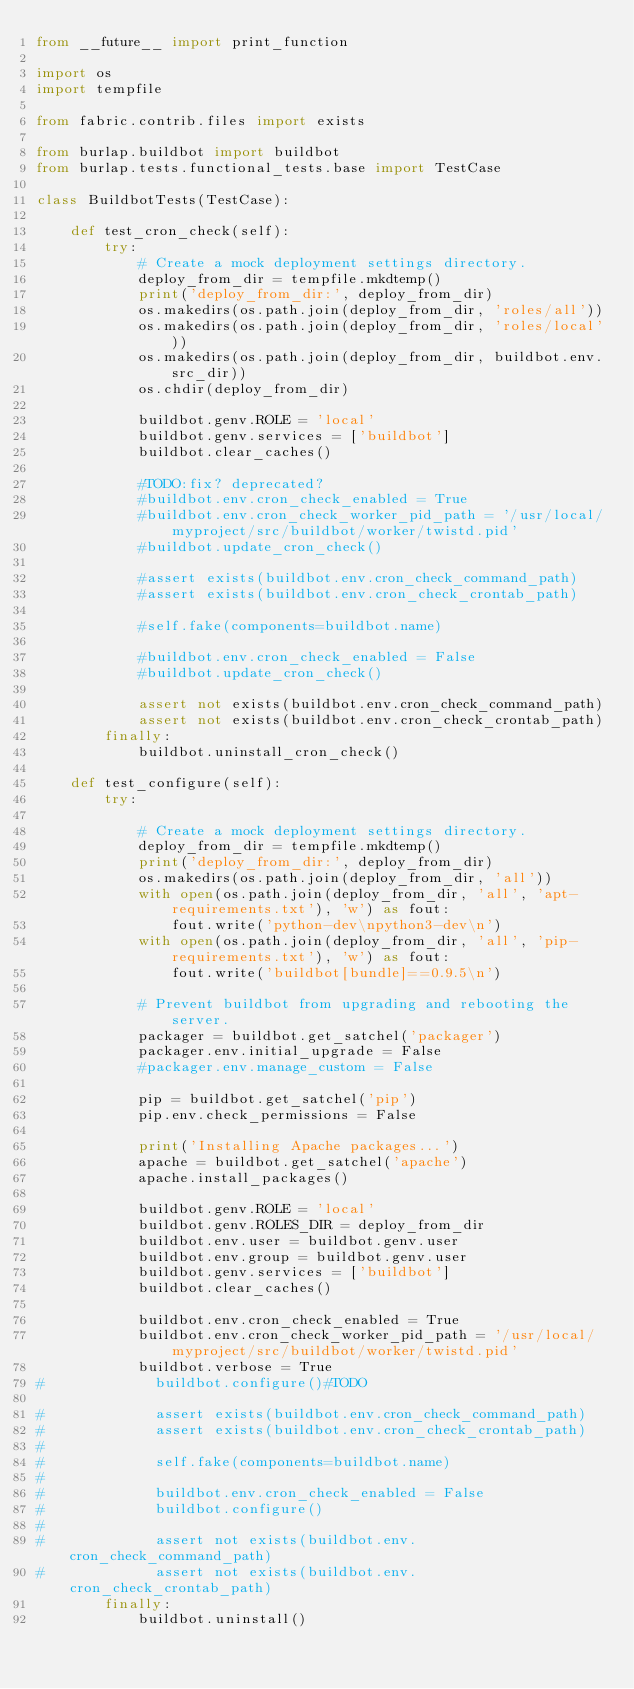Convert code to text. <code><loc_0><loc_0><loc_500><loc_500><_Python_>from __future__ import print_function

import os
import tempfile

from fabric.contrib.files import exists

from burlap.buildbot import buildbot
from burlap.tests.functional_tests.base import TestCase

class BuildbotTests(TestCase):

    def test_cron_check(self):
        try:
            # Create a mock deployment settings directory.
            deploy_from_dir = tempfile.mkdtemp()
            print('deploy_from_dir:', deploy_from_dir)
            os.makedirs(os.path.join(deploy_from_dir, 'roles/all'))
            os.makedirs(os.path.join(deploy_from_dir, 'roles/local'))
            os.makedirs(os.path.join(deploy_from_dir, buildbot.env.src_dir))
            os.chdir(deploy_from_dir)

            buildbot.genv.ROLE = 'local'
            buildbot.genv.services = ['buildbot']
            buildbot.clear_caches()

            #TODO:fix? deprecated?
            #buildbot.env.cron_check_enabled = True
            #buildbot.env.cron_check_worker_pid_path = '/usr/local/myproject/src/buildbot/worker/twistd.pid'
            #buildbot.update_cron_check()

            #assert exists(buildbot.env.cron_check_command_path)
            #assert exists(buildbot.env.cron_check_crontab_path)

            #self.fake(components=buildbot.name)

            #buildbot.env.cron_check_enabled = False
            #buildbot.update_cron_check()

            assert not exists(buildbot.env.cron_check_command_path)
            assert not exists(buildbot.env.cron_check_crontab_path)
        finally:
            buildbot.uninstall_cron_check()

    def test_configure(self):
        try:

            # Create a mock deployment settings directory.
            deploy_from_dir = tempfile.mkdtemp()
            print('deploy_from_dir:', deploy_from_dir)
            os.makedirs(os.path.join(deploy_from_dir, 'all'))
            with open(os.path.join(deploy_from_dir, 'all', 'apt-requirements.txt'), 'w') as fout:
                fout.write('python-dev\npython3-dev\n')
            with open(os.path.join(deploy_from_dir, 'all', 'pip-requirements.txt'), 'w') as fout:
                fout.write('buildbot[bundle]==0.9.5\n')

            # Prevent buildbot from upgrading and rebooting the server.
            packager = buildbot.get_satchel('packager')
            packager.env.initial_upgrade = False
            #packager.env.manage_custom = False

            pip = buildbot.get_satchel('pip')
            pip.env.check_permissions = False

            print('Installing Apache packages...')
            apache = buildbot.get_satchel('apache')
            apache.install_packages()

            buildbot.genv.ROLE = 'local'
            buildbot.genv.ROLES_DIR = deploy_from_dir
            buildbot.env.user = buildbot.genv.user
            buildbot.env.group = buildbot.genv.user
            buildbot.genv.services = ['buildbot']
            buildbot.clear_caches()

            buildbot.env.cron_check_enabled = True
            buildbot.env.cron_check_worker_pid_path = '/usr/local/myproject/src/buildbot/worker/twistd.pid'
            buildbot.verbose = True
#             buildbot.configure()#TODO

#             assert exists(buildbot.env.cron_check_command_path)
#             assert exists(buildbot.env.cron_check_crontab_path)
#
#             self.fake(components=buildbot.name)
#
#             buildbot.env.cron_check_enabled = False
#             buildbot.configure()
#
#             assert not exists(buildbot.env.cron_check_command_path)
#             assert not exists(buildbot.env.cron_check_crontab_path)
        finally:
            buildbot.uninstall()
</code> 